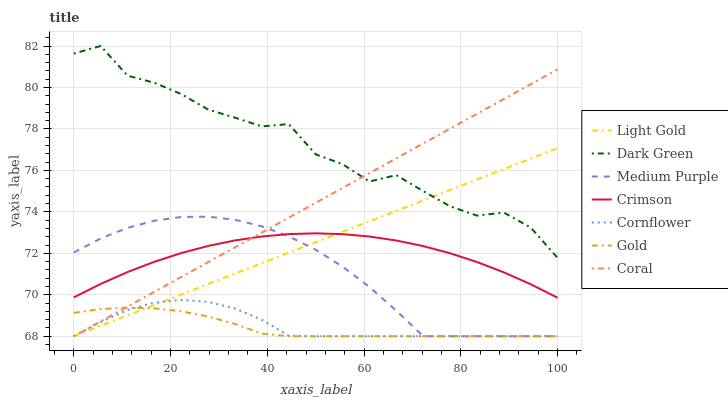Does Gold have the minimum area under the curve?
Answer yes or no. Yes. Does Dark Green have the maximum area under the curve?
Answer yes or no. Yes. Does Coral have the minimum area under the curve?
Answer yes or no. No. Does Coral have the maximum area under the curve?
Answer yes or no. No. Is Light Gold the smoothest?
Answer yes or no. Yes. Is Dark Green the roughest?
Answer yes or no. Yes. Is Gold the smoothest?
Answer yes or no. No. Is Gold the roughest?
Answer yes or no. No. Does Crimson have the lowest value?
Answer yes or no. No. Does Dark Green have the highest value?
Answer yes or no. Yes. Does Coral have the highest value?
Answer yes or no. No. Is Gold less than Dark Green?
Answer yes or no. Yes. Is Dark Green greater than Cornflower?
Answer yes or no. Yes. Does Light Gold intersect Cornflower?
Answer yes or no. Yes. Is Light Gold less than Cornflower?
Answer yes or no. No. Is Light Gold greater than Cornflower?
Answer yes or no. No. Does Gold intersect Dark Green?
Answer yes or no. No. 